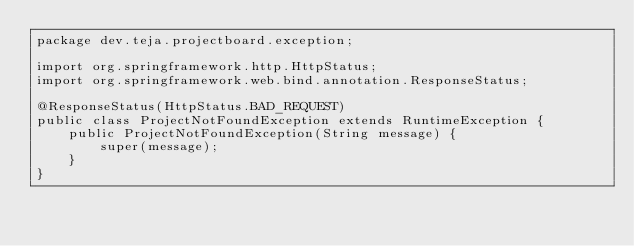Convert code to text. <code><loc_0><loc_0><loc_500><loc_500><_Java_>package dev.teja.projectboard.exception;

import org.springframework.http.HttpStatus;
import org.springframework.web.bind.annotation.ResponseStatus;

@ResponseStatus(HttpStatus.BAD_REQUEST)
public class ProjectNotFoundException extends RuntimeException {
    public ProjectNotFoundException(String message) {
        super(message);
    }
}
</code> 